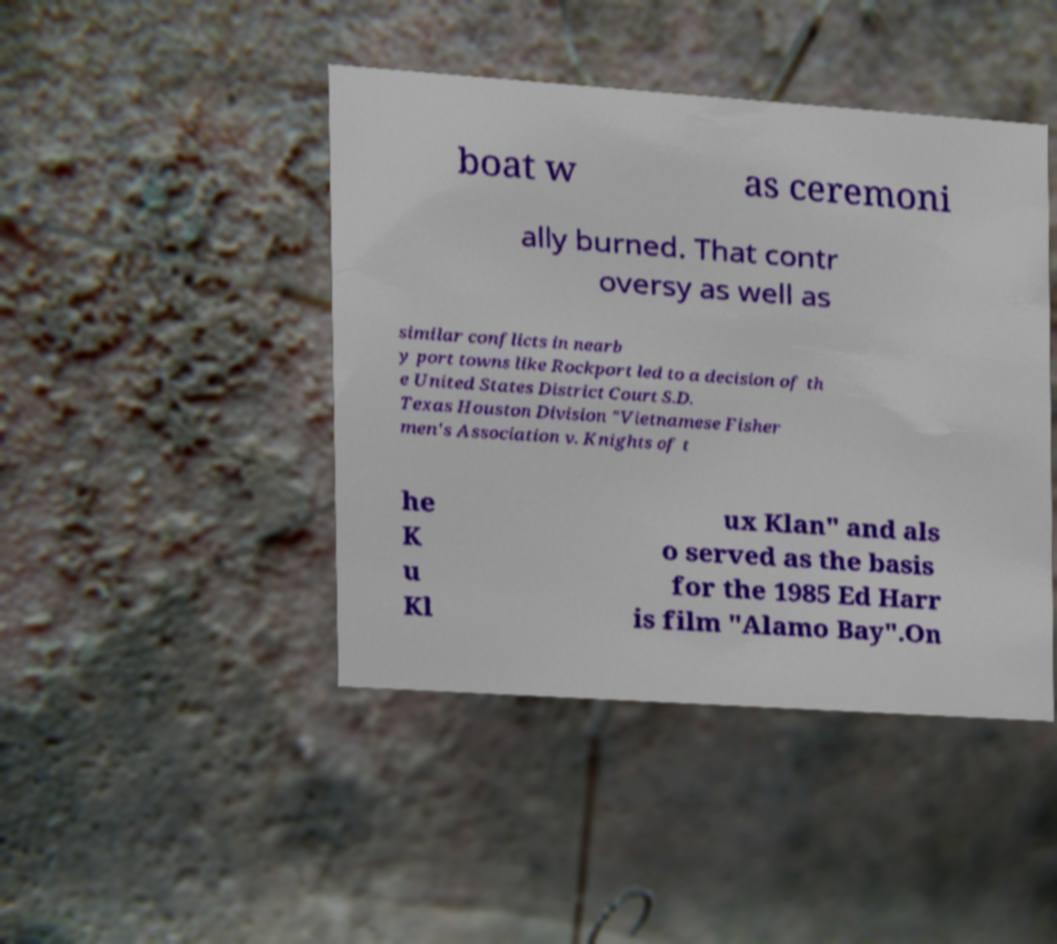Can you accurately transcribe the text from the provided image for me? boat w as ceremoni ally burned. That contr oversy as well as similar conflicts in nearb y port towns like Rockport led to a decision of th e United States District Court S.D. Texas Houston Division "Vietnamese Fisher men's Association v. Knights of t he K u Kl ux Klan" and als o served as the basis for the 1985 Ed Harr is film "Alamo Bay".On 